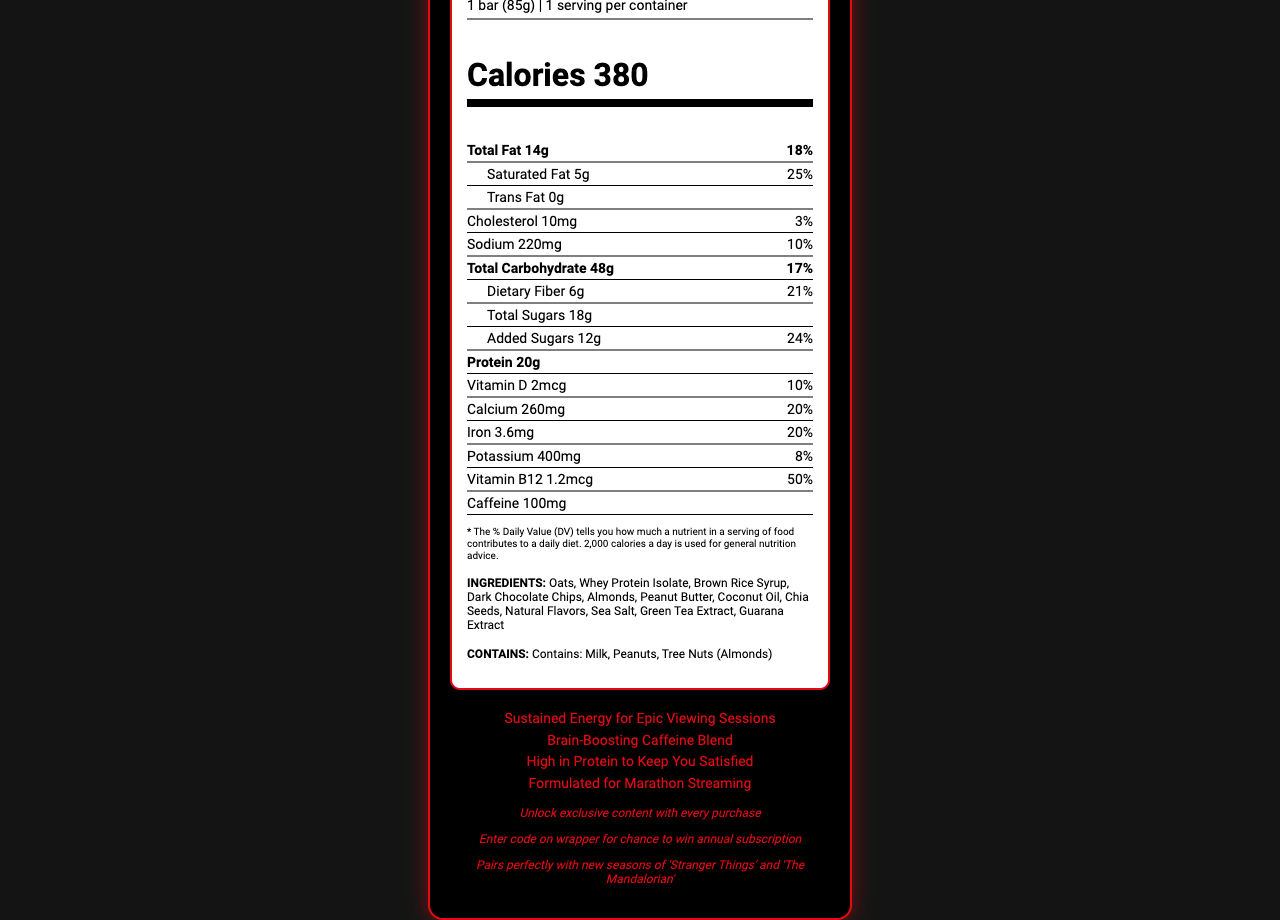what is the serving size of the StreamFeast Ultimate Binge Bar? The serving size is listed near the top of the document under the nutrition facts section.
Answer: 1 bar (85g) how many calories does one StreamFeast Ultimate Binge Bar contain? The calorie count is prominently displayed in a large font under the serving size and servings per container.
Answer: 380 How much protein is in one StreamFeast Ultimate Binge Bar? The protein amount is listed under the nutrition facts section as "Protein 20g".
Answer: 20g What is the daily value percentage of saturated fat in the StreamFeast Ultimate Binge Bar? The daily value percentage for saturated fat is listed as "25%" right next to "Saturated Fat 5g" under the total fat section.
Answer: 25% How much caffeine content is in the StreamFeast Ultimate Binge Bar? Caffeine content is listed towards the bottom of the nutrition facts section as "Caffeine 100mg".
Answer: 100mg which ingredient is not part of the StreamFeast Ultimate Binge Bar? A. Oats B. Soy Protein Isolate C. Dark Chocolate Chips The listed ingredients include "Oats" and "Dark Chocolate Chips" but not "Soy Protein Isolate".
Answer: B. Soy Protein Isolate Which of the following vitamins listed is the highest in daily value percentage? I. Vitamin D II. Calcium III. Vitamin B12 Vitamin B12 has a daily value percentage of 50%, which is the highest compared to Vitamin D (10%) and Calcium (20%).
Answer: III. Vitamin B12 Does the StreamFeast Ultimate Binge Bar contain any cholesterol? The document lists "Cholesterol 10mg" with a daily value of "3%".
Answer: Yes How many servings per container are there for the StreamFeast Ultimate Binge Bar? The document clearly states "1 serving per container" near the top of the nutrition facts section.
Answer: 1 How would you describe the main idea of this document? The main content of the document includes the nutritional breakdown, ingredients, allergens, and promotional tie-ins of the StreamFeast Ultimate Binge Bar designed for long viewing periods.
Answer: The document provides detailed nutrition information for the StreamFeast Ultimate Binge Bar, highlighting its caloric content, macronutrients, vitamins, minerals, ingredients, allergen information, and marketing claims focused on long streaming sessions. It also contains special promotions tied to popular streaming shows. how much green tea extract is in the StreamFeast Ultimate Binge Bar? The document lists "Green Tea Extract" in the ingredients but does not specify the quantity.
Answer: Not enough information 